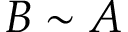<formula> <loc_0><loc_0><loc_500><loc_500>B \sim A</formula> 